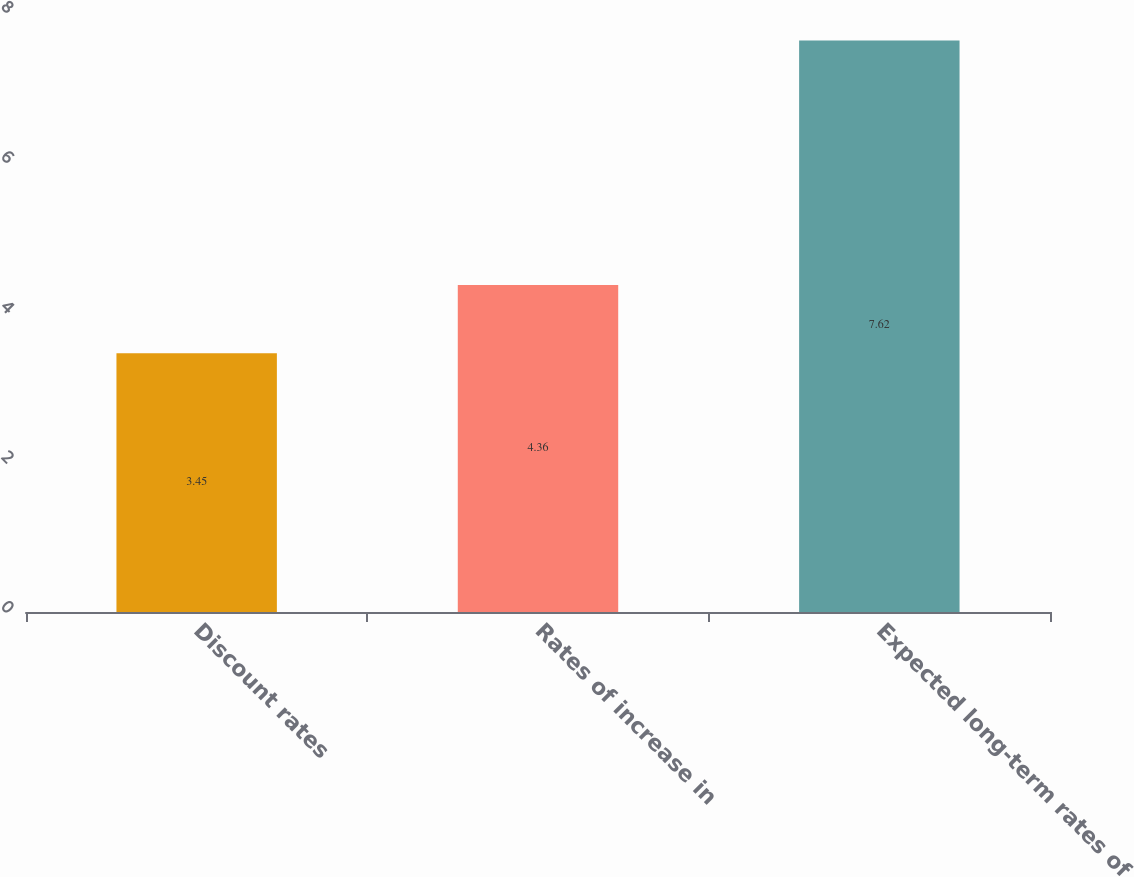Convert chart to OTSL. <chart><loc_0><loc_0><loc_500><loc_500><bar_chart><fcel>Discount rates<fcel>Rates of increase in<fcel>Expected long-term rates of<nl><fcel>3.45<fcel>4.36<fcel>7.62<nl></chart> 